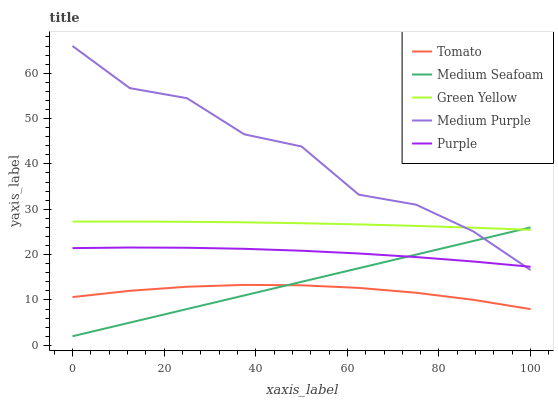Does Tomato have the minimum area under the curve?
Answer yes or no. Yes. Does Medium Purple have the maximum area under the curve?
Answer yes or no. Yes. Does Green Yellow have the minimum area under the curve?
Answer yes or no. No. Does Green Yellow have the maximum area under the curve?
Answer yes or no. No. Is Medium Seafoam the smoothest?
Answer yes or no. Yes. Is Medium Purple the roughest?
Answer yes or no. Yes. Is Green Yellow the smoothest?
Answer yes or no. No. Is Green Yellow the roughest?
Answer yes or no. No. Does Medium Seafoam have the lowest value?
Answer yes or no. Yes. Does Medium Purple have the lowest value?
Answer yes or no. No. Does Medium Purple have the highest value?
Answer yes or no. Yes. Does Green Yellow have the highest value?
Answer yes or no. No. Is Tomato less than Green Yellow?
Answer yes or no. Yes. Is Medium Purple greater than Tomato?
Answer yes or no. Yes. Does Medium Purple intersect Medium Seafoam?
Answer yes or no. Yes. Is Medium Purple less than Medium Seafoam?
Answer yes or no. No. Is Medium Purple greater than Medium Seafoam?
Answer yes or no. No. Does Tomato intersect Green Yellow?
Answer yes or no. No. 